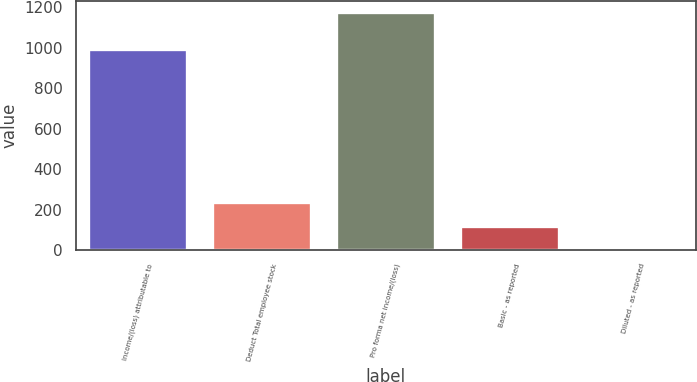Convert chart. <chart><loc_0><loc_0><loc_500><loc_500><bar_chart><fcel>Income/(loss) attributable to<fcel>Deduct Total employee stock<fcel>Pro forma net income/(loss)<fcel>Basic - as reported<fcel>Diluted - as reported<nl><fcel>995<fcel>235.24<fcel>1174<fcel>117.89<fcel>0.54<nl></chart> 